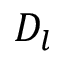Convert formula to latex. <formula><loc_0><loc_0><loc_500><loc_500>D _ { l }</formula> 